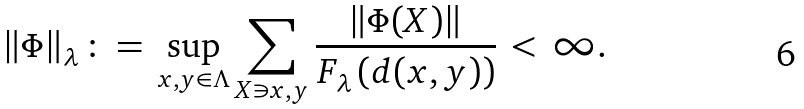Convert formula to latex. <formula><loc_0><loc_0><loc_500><loc_500>\| \Phi \| _ { \lambda } \, \colon = \, \sup _ { x , y \in \Lambda } \sum _ { X \ni x , y } \frac { \| \Phi ( X ) \| } { F _ { \lambda } \left ( d ( x , y ) \right ) } \, < \, \infty .</formula> 